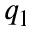<formula> <loc_0><loc_0><loc_500><loc_500>q _ { 1 }</formula> 